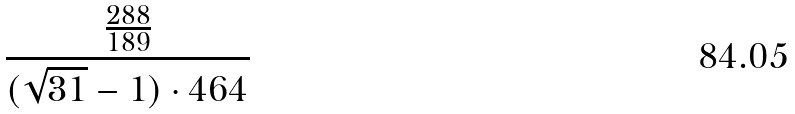<formula> <loc_0><loc_0><loc_500><loc_500>\frac { \frac { 2 8 8 } { 1 8 9 } } { ( \sqrt { 3 1 } - 1 ) \cdot 4 6 4 }</formula> 